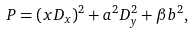Convert formula to latex. <formula><loc_0><loc_0><loc_500><loc_500>P = ( x D _ { x } ) ^ { 2 } + a ^ { 2 } D _ { y } ^ { 2 } + \beta b ^ { 2 } ,</formula> 